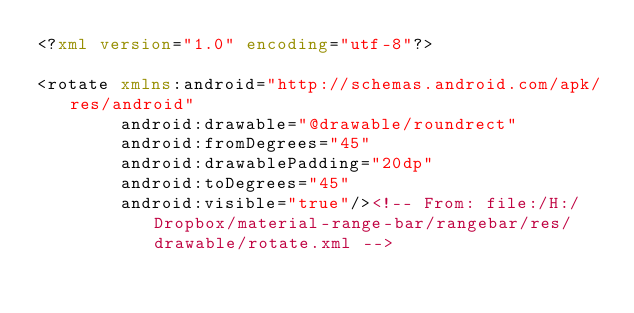<code> <loc_0><loc_0><loc_500><loc_500><_XML_><?xml version="1.0" encoding="utf-8"?>

<rotate xmlns:android="http://schemas.android.com/apk/res/android"
        android:drawable="@drawable/roundrect"
        android:fromDegrees="45"
        android:drawablePadding="20dp"
        android:toDegrees="45"
        android:visible="true"/><!-- From: file:/H:/Dropbox/material-range-bar/rangebar/res/drawable/rotate.xml --></code> 